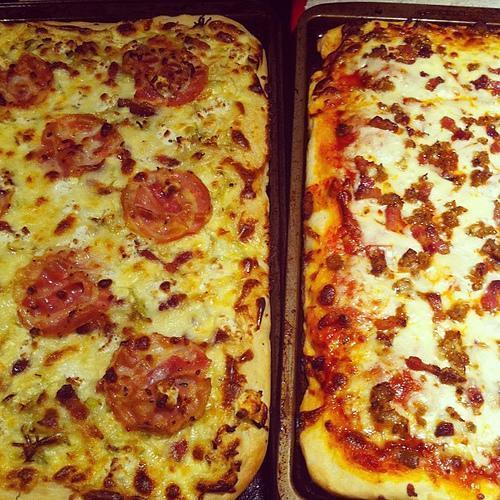How many pizzas are there?
Give a very brief answer. 2. 